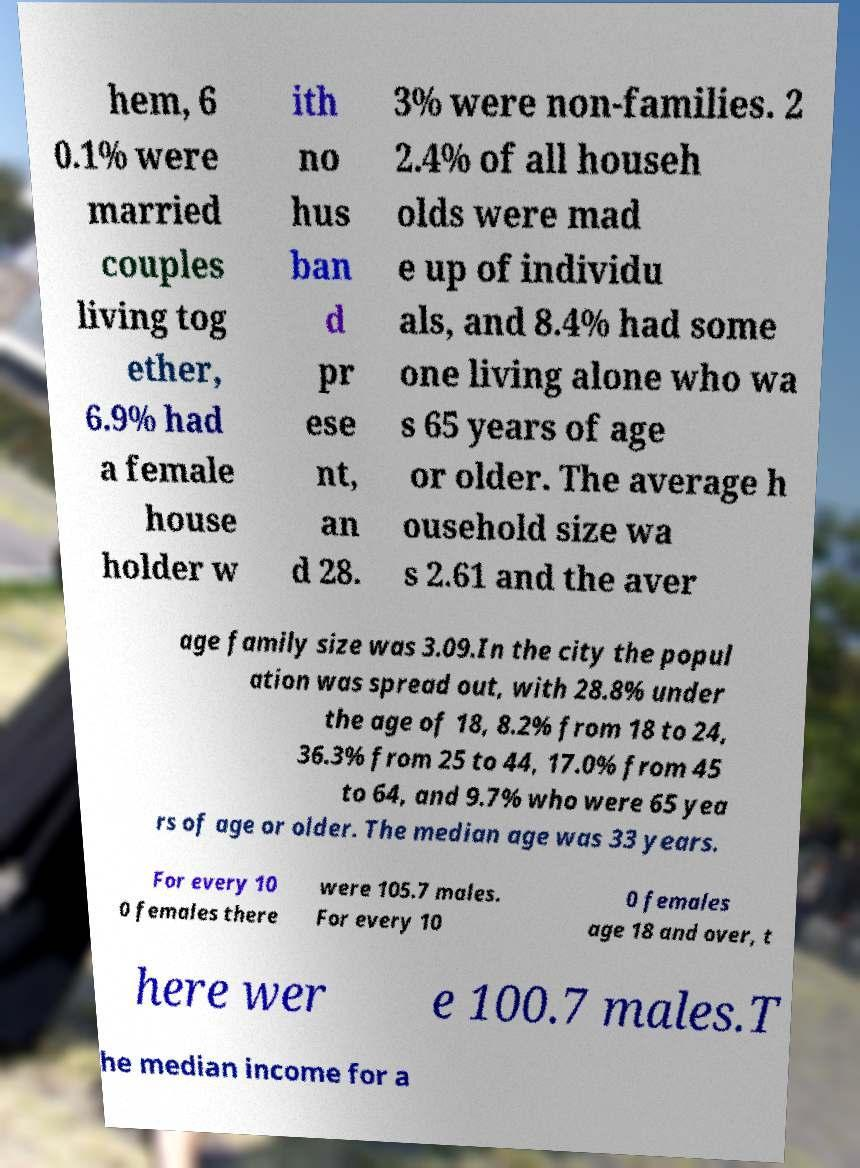There's text embedded in this image that I need extracted. Can you transcribe it verbatim? hem, 6 0.1% were married couples living tog ether, 6.9% had a female house holder w ith no hus ban d pr ese nt, an d 28. 3% were non-families. 2 2.4% of all househ olds were mad e up of individu als, and 8.4% had some one living alone who wa s 65 years of age or older. The average h ousehold size wa s 2.61 and the aver age family size was 3.09.In the city the popul ation was spread out, with 28.8% under the age of 18, 8.2% from 18 to 24, 36.3% from 25 to 44, 17.0% from 45 to 64, and 9.7% who were 65 yea rs of age or older. The median age was 33 years. For every 10 0 females there were 105.7 males. For every 10 0 females age 18 and over, t here wer e 100.7 males.T he median income for a 